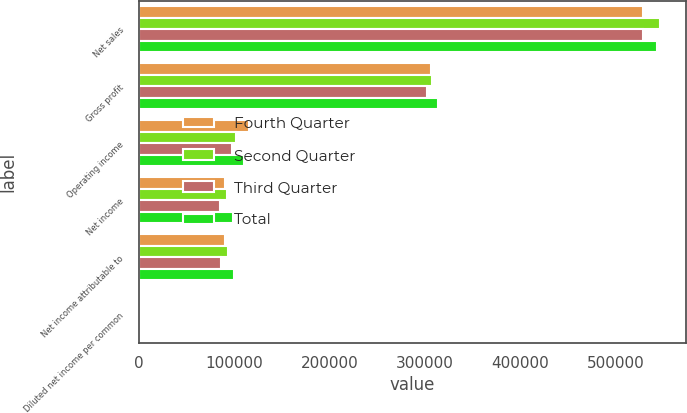<chart> <loc_0><loc_0><loc_500><loc_500><stacked_bar_chart><ecel><fcel>Net sales<fcel>Gross profit<fcel>Operating income<fcel>Net income<fcel>Net income attributable to<fcel>Diluted net income per common<nl><fcel>Fourth Quarter<fcel>528876<fcel>306519<fcel>115946<fcel>89909<fcel>89909<fcel>0.4<nl><fcel>Second Quarter<fcel>546243<fcel>307454<fcel>101318<fcel>92038<fcel>93641<fcel>0.42<nl><fcel>Third Quarter<fcel>528710<fcel>301959<fcel>98009<fcel>84798<fcel>86057<fcel>0.39<nl><fcel>Total<fcel>543207<fcel>313632<fcel>110347<fcel>98580<fcel>99402<fcel>0.45<nl></chart> 